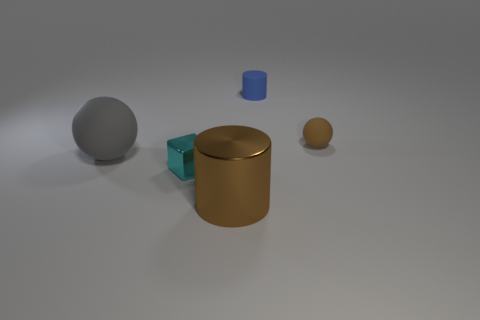Add 3 large gray matte balls. How many objects exist? 8 Subtract all cylinders. How many objects are left? 3 Subtract all small blue rubber balls. Subtract all big brown metal objects. How many objects are left? 4 Add 1 big gray things. How many big gray things are left? 2 Add 5 big brown cubes. How many big brown cubes exist? 5 Subtract 0 brown blocks. How many objects are left? 5 